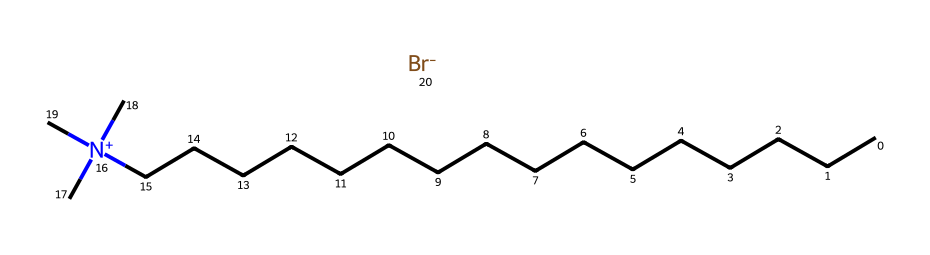What is the total number of carbon atoms in cetrimonium bromide? The chemical structure shows a long hydrocarbon chain followed by a nitrogen atom connected to three carbon atoms (indicated by three methyl groups). Counting the carbons in the chain (16) and the three from the nitrogen gives a total of 19 carbon atoms.
Answer: nineteen How many nitrogen atoms are present in cetrimonium bromide? The SMILES representation shows the presence of a nitrogen atom denoted by "N". There is only one nitrogen in the structure.
Answer: one What type of surfactant is cetrimonium bromide? Cetrimonium bromide contains a positively charged nitrogen atom, which indicates it is a cationic surfactant. This classification is due to its structure featuring a quaternary ammonium group.
Answer: cationic How many bromine atoms are present in cetrimonium bromide? The chemical structure includes "[Br-]", indicating the presence of one bromine atom in the compound. Counting the instances of bromine gives a total of one.
Answer: one What is the molecular formula of cetrimonium bromide based on its structure? The compound contains 19 carbon atoms, 42 hydrogen atoms, 1 nitrogen atom, and 1 bromine atom. By combining these counts, the molecular formula can be calculated as C19H42BrN.
Answer: C19H42BrN Which part of the cetrimonium bromide contributes to its antistatic properties? The cationic nature of cetrimonium bromide, specifically the positively charged nitrogen atom, allows it to neutralize static charges on surfaces, providing antistatic properties.
Answer: positively charged nitrogen 